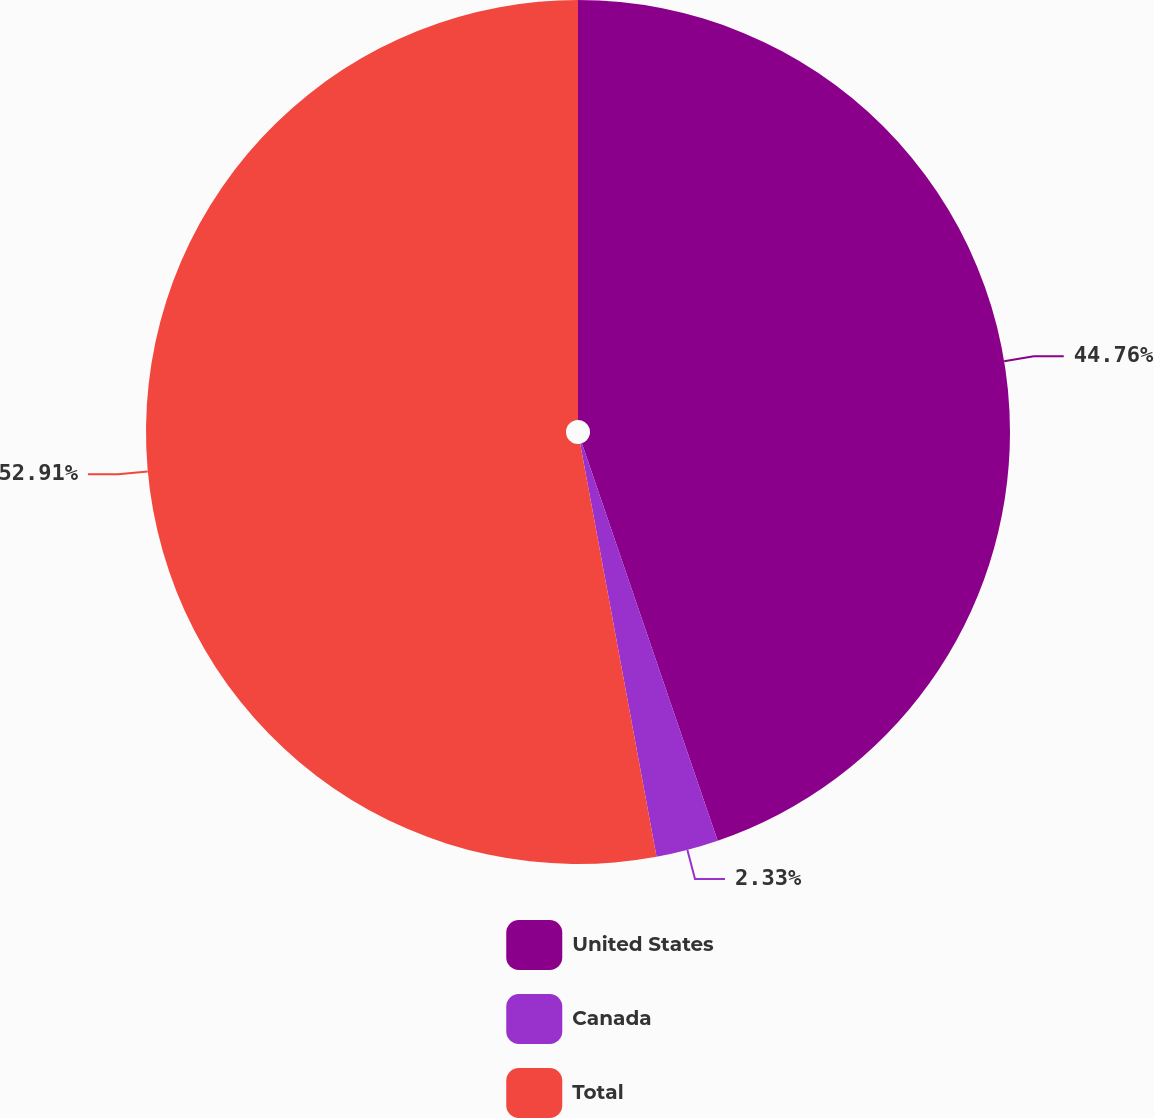Convert chart to OTSL. <chart><loc_0><loc_0><loc_500><loc_500><pie_chart><fcel>United States<fcel>Canada<fcel>Total<nl><fcel>44.76%<fcel>2.33%<fcel>52.91%<nl></chart> 